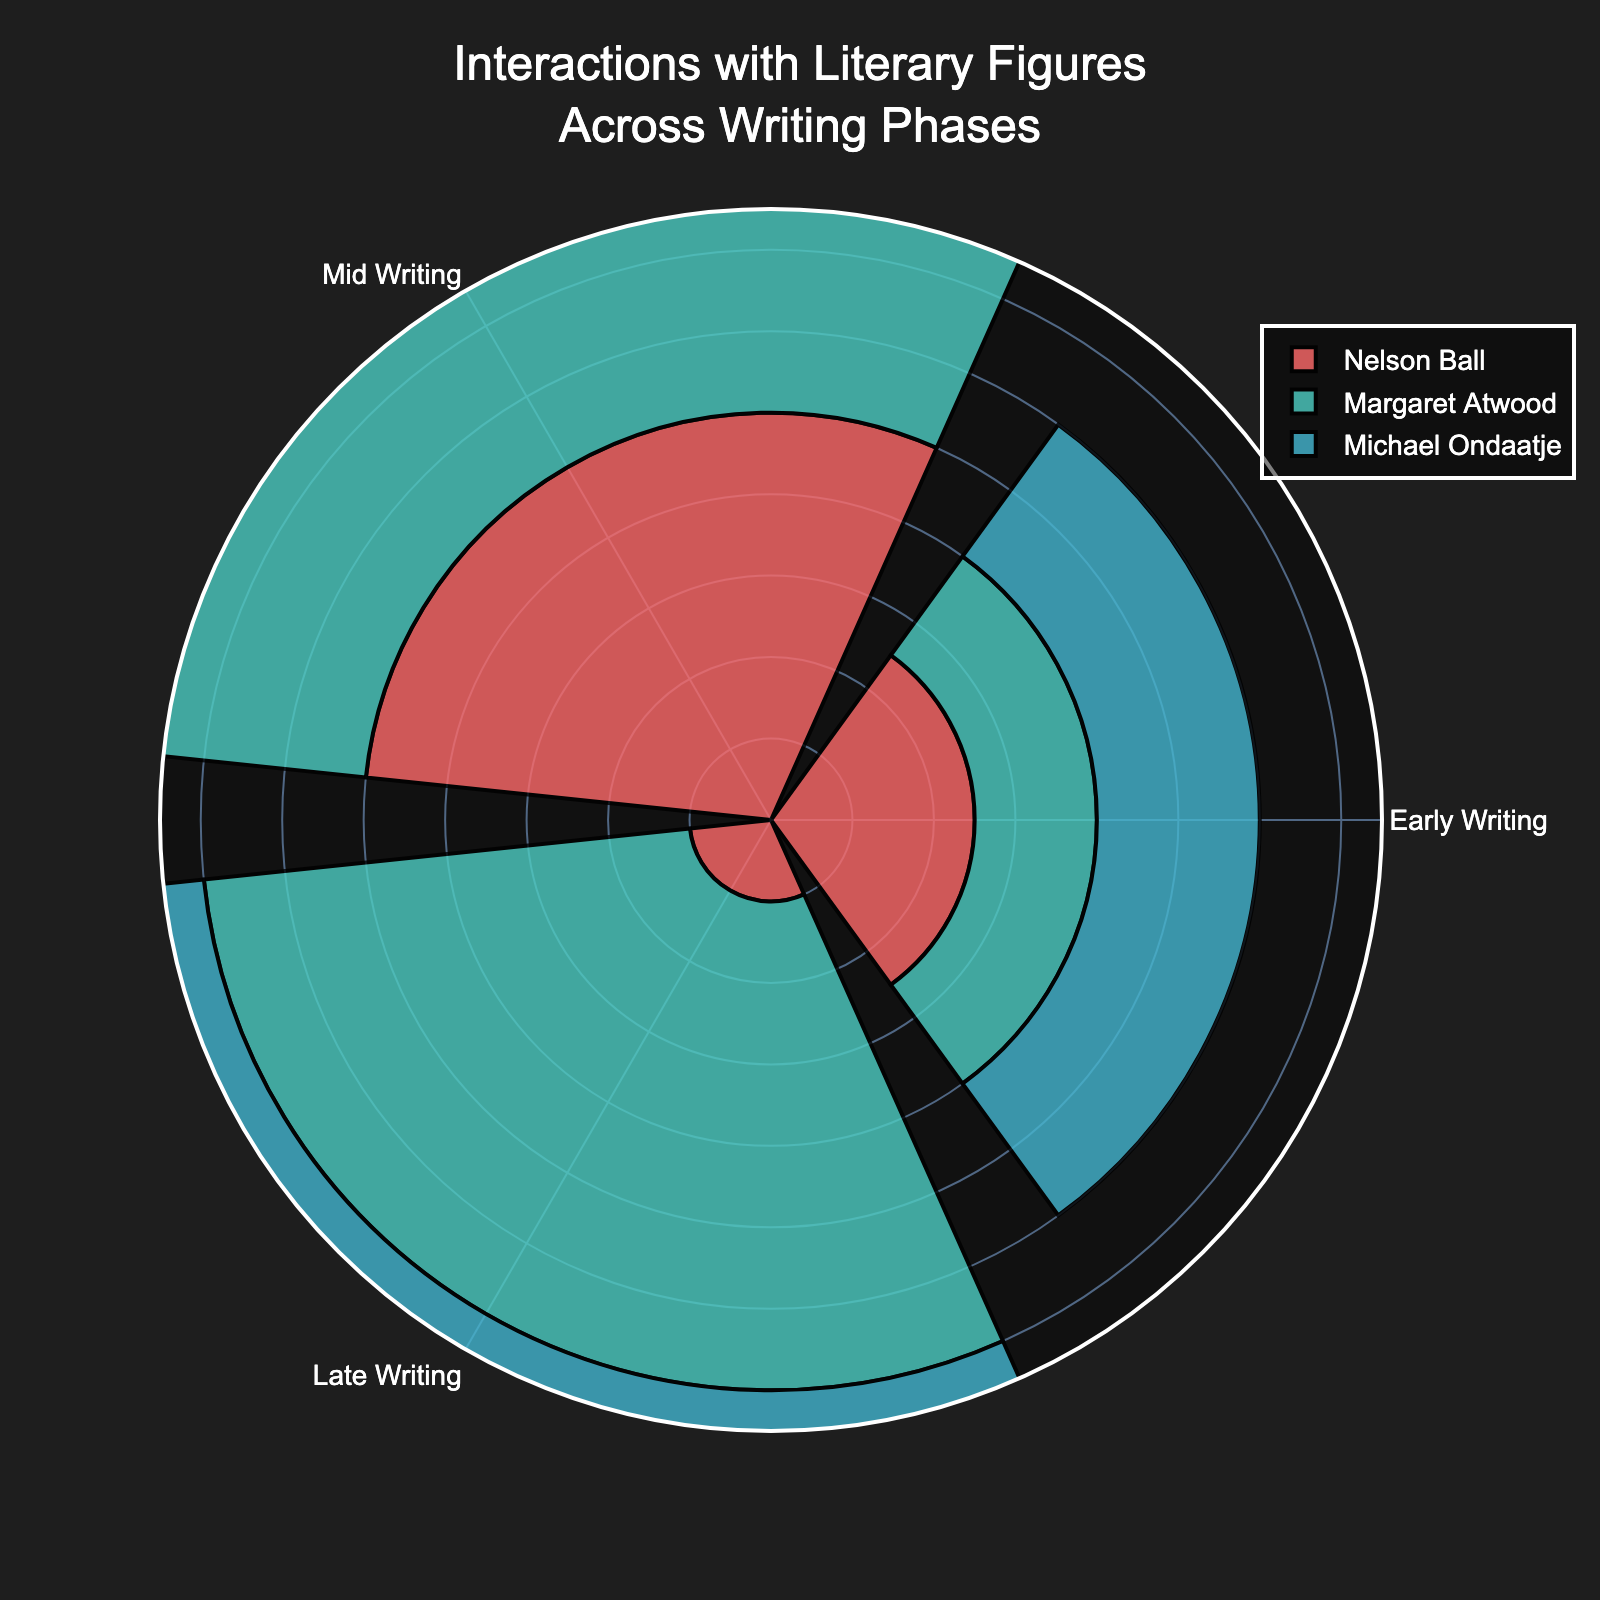What is the title of the figure? The title is located at the top of the plot and stands out due to its font size and color against the dark background. It clearly states what the chart represents.
Answer: Interactions with Literary Figures Across Writing Phases Which phase had the highest interactions with Nelson Ball? Looking at the plot, the segment with the highest radius for Nelson Ball (marked with a specific color) corresponds to the Mid Writing phase.
Answer: Mid Writing How many interactions did Michael Ondaatje have in the Late Writing phase? Each bar in the plot represents the interactions for a specific writer in different phases. By checking Michael Ondaatje's color coding, we can find the corresponding segment in the Late Writing phase.
Answer: 3 Compare the interactions with Margaret Atwood in the Early Writing and Mid Writing phases. Which is higher and by how much? We first identify the segments for Margaret Atwood in the Early Writing and Mid Writing phases and compare the lengths visually. By subtracting the values, we get the difference.
Answer: Mid Writing by 5 At which phase did Alice Munro have more interactions, Mid Writing or Late Writing? We look at the bar lengths for Alice Munro in both the Mid Writing and Late Writing phases and compare them. The longer bar indicates more interactions.
Answer: Late Writing Sum the interactions with Nelson Ball across all phases. We add the interaction values for Nelson Ball across Early Writing, Mid Writing, and Late Writing phases as indicated by the lengths of the respective bars.
Answer: 17 Which writer has the most interactions in the Late Writing phase? By examining which bar extends the most in the Late Writing phase segment, we identify the writer with the highest interactions.
Answer: Margaret Atwood What is the average number of interactions with Margaret Atwood across all phases? Add the interactions with Margaret Atwood in Early Writing, Mid Writing, and Late Writing phases, then divide by the number of phases (3).
Answer: 7.67 Which phase saw the lowest interactions with literary figures overall? For each phase, sum the interactions of all writers and then compare the totals across phases to determine the lowest.
Answer: Early Writing Are the interactions with Michael Ondaatje in the Mid Writing phase equal to the sum of interactions with Alice Munro in Early and Mid Writing phases? Check the interaction value for Michael Ondaatje in the Mid Writing phase and sum Alice Munro's interactions in Early and Mid Writing phases, then compare both values.
Answer: No 